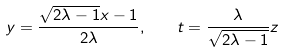Convert formula to latex. <formula><loc_0><loc_0><loc_500><loc_500>y = \frac { \sqrt { 2 \lambda - 1 } x - 1 } { 2 \lambda } , \quad t = \frac { \lambda } { \sqrt { 2 \lambda - 1 } } z</formula> 